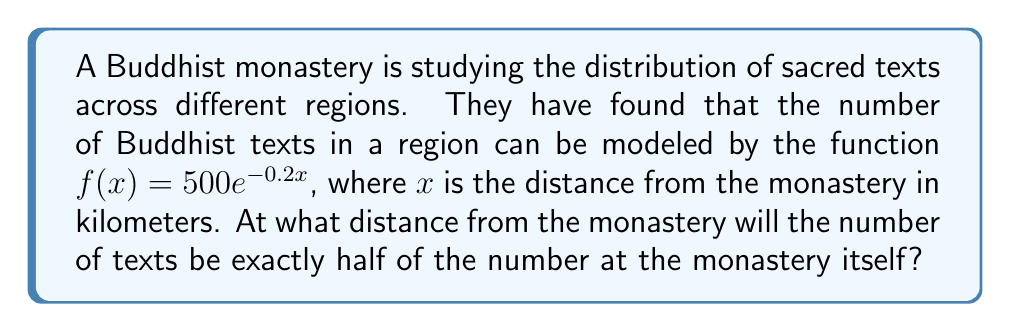Show me your answer to this math problem. Let's approach this step-by-step:

1) At the monastery itself, $x = 0$. So the number of texts at the monastery is:
   $f(0) = 500e^{-0.2(0)} = 500$

2) We want to find the distance $x$ where the number of texts is half of this. So we're looking for:
   $f(x) = 250$

3) Let's set up the equation:
   $500e^{-0.2x} = 250$

4) Divide both sides by 500:
   $e^{-0.2x} = 0.5$

5) Take the natural log of both sides:
   $\ln(e^{-0.2x}) = \ln(0.5)$
   $-0.2x = \ln(0.5)$

6) Divide both sides by -0.2:
   $x = -\frac{\ln(0.5)}{0.2}$

7) Calculate the value:
   $x = -\frac{\ln(0.5)}{0.2} \approx 3.466$ km

Therefore, the number of texts will be exactly half at approximately 3.466 km from the monastery.
Answer: $-\frac{\ln(0.5)}{0.2}$ km 